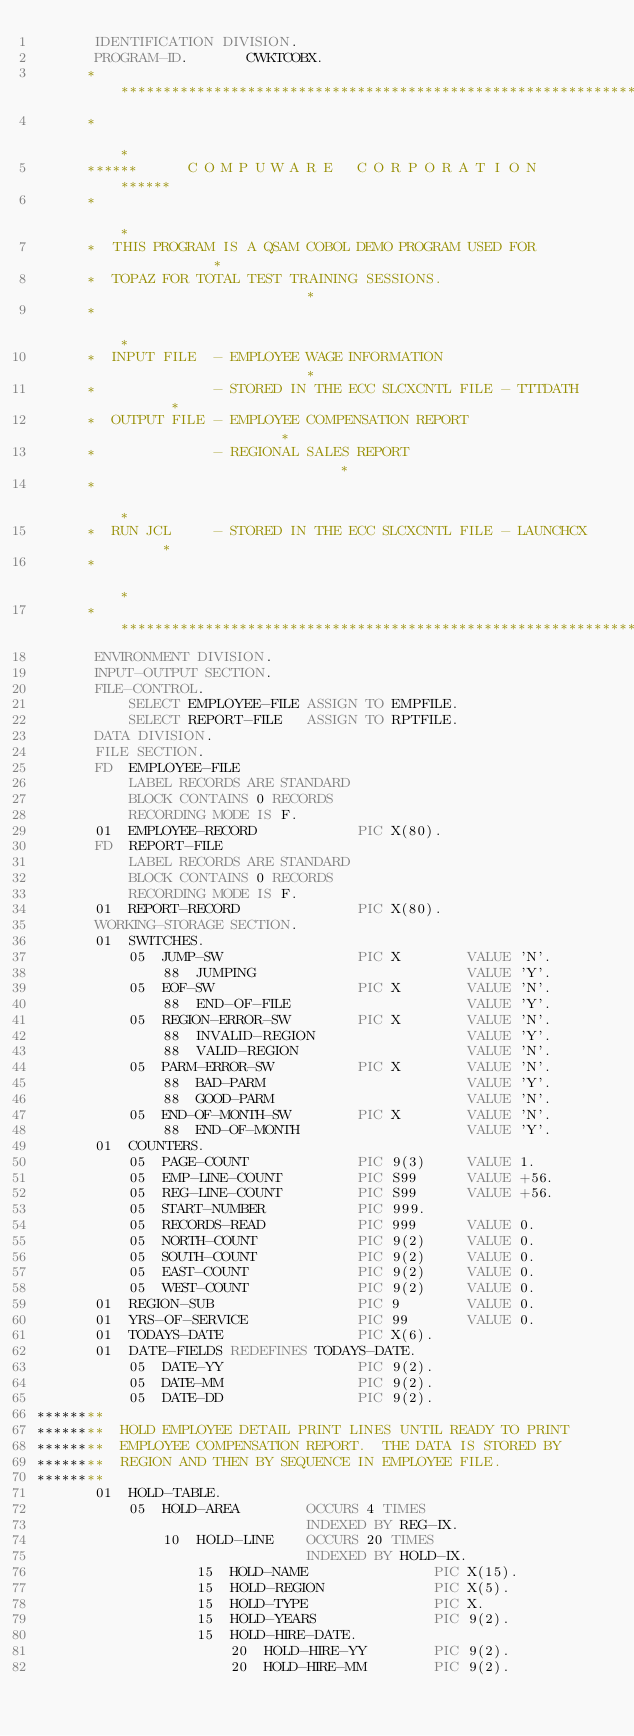Convert code to text. <code><loc_0><loc_0><loc_500><loc_500><_COBOL_>       IDENTIFICATION DIVISION.
       PROGRAM-ID.       CWKTCOBX.
      ******************************************************************
      *                                                                *
      ******      C O M P U W A R E   C O R P O R A T I O N       ******
      *                                                                *
      *  THIS PROGRAM IS A QSAM COBOL DEMO PROGRAM USED FOR            *
      *  TOPAZ FOR TOTAL TEST TRAINING SESSIONS.                       *
      *                                                                *
      *  INPUT FILE  - EMPLOYEE WAGE INFORMATION                       *
      *              - STORED IN THE ECC SLCXCNTL FILE - TTTDATH       *
      *  OUTPUT FILE - EMPLOYEE COMPENSATION REPORT                    *
      *              - REGIONAL SALES REPORT                           *
      *                                                                *
      *  RUN JCL     - STORED IN THE ECC SLCXCNTL FILE - LAUNCHCX      *
      *                                                                *
      ******************************************************************
       ENVIRONMENT DIVISION.
       INPUT-OUTPUT SECTION.
       FILE-CONTROL.
           SELECT EMPLOYEE-FILE ASSIGN TO EMPFILE.
           SELECT REPORT-FILE   ASSIGN TO RPTFILE.
       DATA DIVISION.
       FILE SECTION.
       FD  EMPLOYEE-FILE
           LABEL RECORDS ARE STANDARD
           BLOCK CONTAINS 0 RECORDS
           RECORDING MODE IS F.
       01  EMPLOYEE-RECORD            PIC X(80).
       FD  REPORT-FILE
           LABEL RECORDS ARE STANDARD
           BLOCK CONTAINS 0 RECORDS
           RECORDING MODE IS F.
       01  REPORT-RECORD              PIC X(80).
       WORKING-STORAGE SECTION.
       01  SWITCHES.
           05  JUMP-SW                PIC X        VALUE 'N'.
               88  JUMPING                         VALUE 'Y'.
           05  EOF-SW                 PIC X        VALUE 'N'.
               88  END-OF-FILE                     VALUE 'Y'.
           05  REGION-ERROR-SW        PIC X        VALUE 'N'.
               88  INVALID-REGION                  VALUE 'Y'.
               88  VALID-REGION                    VALUE 'N'.
           05  PARM-ERROR-SW          PIC X        VALUE 'N'.
               88  BAD-PARM                        VALUE 'Y'.
               88  GOOD-PARM                       VALUE 'N'.
           05  END-OF-MONTH-SW        PIC X        VALUE 'N'.
               88  END-OF-MONTH                    VALUE 'Y'.
       01  COUNTERS.
           05  PAGE-COUNT             PIC 9(3)     VALUE 1.
           05  EMP-LINE-COUNT         PIC S99      VALUE +56.
           05  REG-LINE-COUNT         PIC S99      VALUE +56.
           05  START-NUMBER           PIC 999.
           05  RECORDS-READ           PIC 999      VALUE 0.
           05  NORTH-COUNT            PIC 9(2)     VALUE 0.
           05  SOUTH-COUNT            PIC 9(2)     VALUE 0.
           05  EAST-COUNT             PIC 9(2)     VALUE 0.
           05  WEST-COUNT             PIC 9(2)     VALUE 0.
       01  REGION-SUB                 PIC 9        VALUE 0.
       01  YRS-OF-SERVICE             PIC 99       VALUE 0.
       01  TODAYS-DATE                PIC X(6).
       01  DATE-FIELDS REDEFINES TODAYS-DATE.
           05  DATE-YY                PIC 9(2).
           05  DATE-MM                PIC 9(2).
           05  DATE-DD                PIC 9(2).
********
********  HOLD EMPLOYEE DETAIL PRINT LINES UNTIL READY TO PRINT
********  EMPLOYEE COMPENSATION REPORT.  THE DATA IS STORED BY
********  REGION AND THEN BY SEQUENCE IN EMPLOYEE FILE.
********
       01  HOLD-TABLE.
           05  HOLD-AREA        OCCURS 4 TIMES
                                INDEXED BY REG-IX.
               10  HOLD-LINE    OCCURS 20 TIMES
                                INDEXED BY HOLD-IX.
                   15  HOLD-NAME               PIC X(15).
                   15  HOLD-REGION             PIC X(5).
                   15  HOLD-TYPE               PIC X.
                   15  HOLD-YEARS              PIC 9(2).
                   15  HOLD-HIRE-DATE.
                       20  HOLD-HIRE-YY        PIC 9(2).
                       20  HOLD-HIRE-MM        PIC 9(2).</code> 